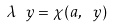<formula> <loc_0><loc_0><loc_500><loc_500>\lambda _ { \ } y = \chi ( a , \ y )</formula> 